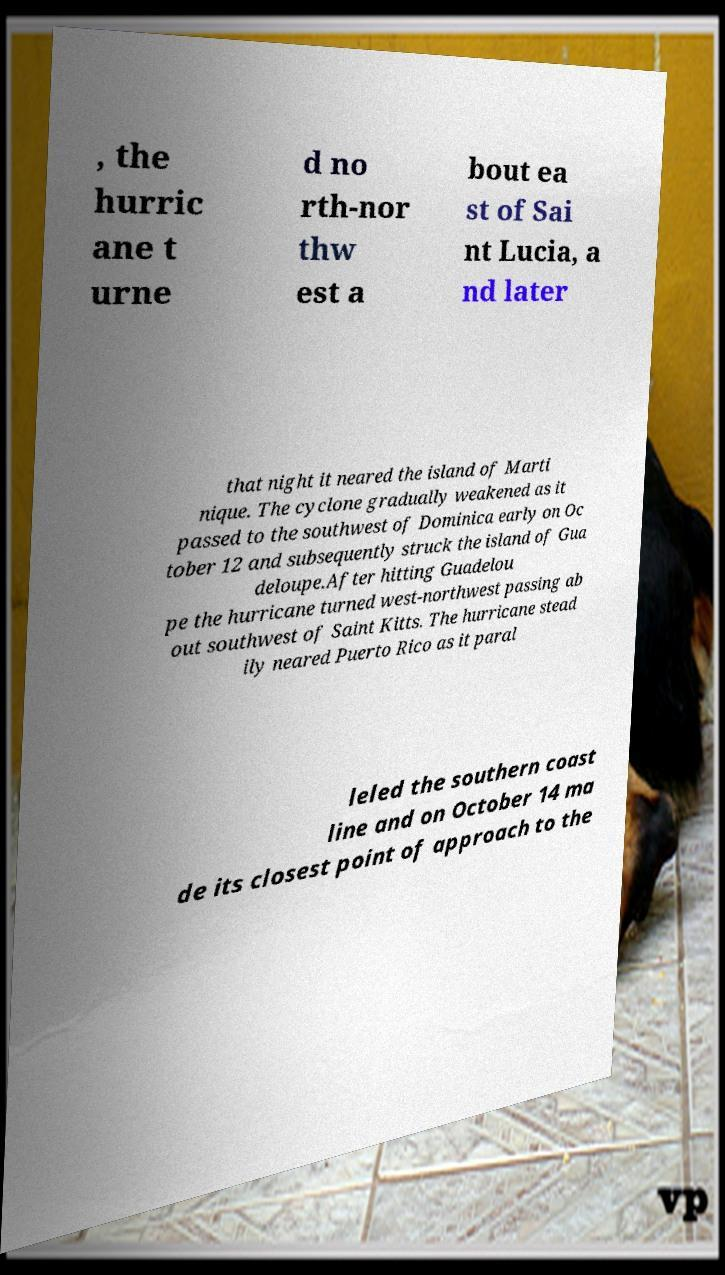Can you read and provide the text displayed in the image?This photo seems to have some interesting text. Can you extract and type it out for me? , the hurric ane t urne d no rth-nor thw est a bout ea st of Sai nt Lucia, a nd later that night it neared the island of Marti nique. The cyclone gradually weakened as it passed to the southwest of Dominica early on Oc tober 12 and subsequently struck the island of Gua deloupe.After hitting Guadelou pe the hurricane turned west-northwest passing ab out southwest of Saint Kitts. The hurricane stead ily neared Puerto Rico as it paral leled the southern coast line and on October 14 ma de its closest point of approach to the 